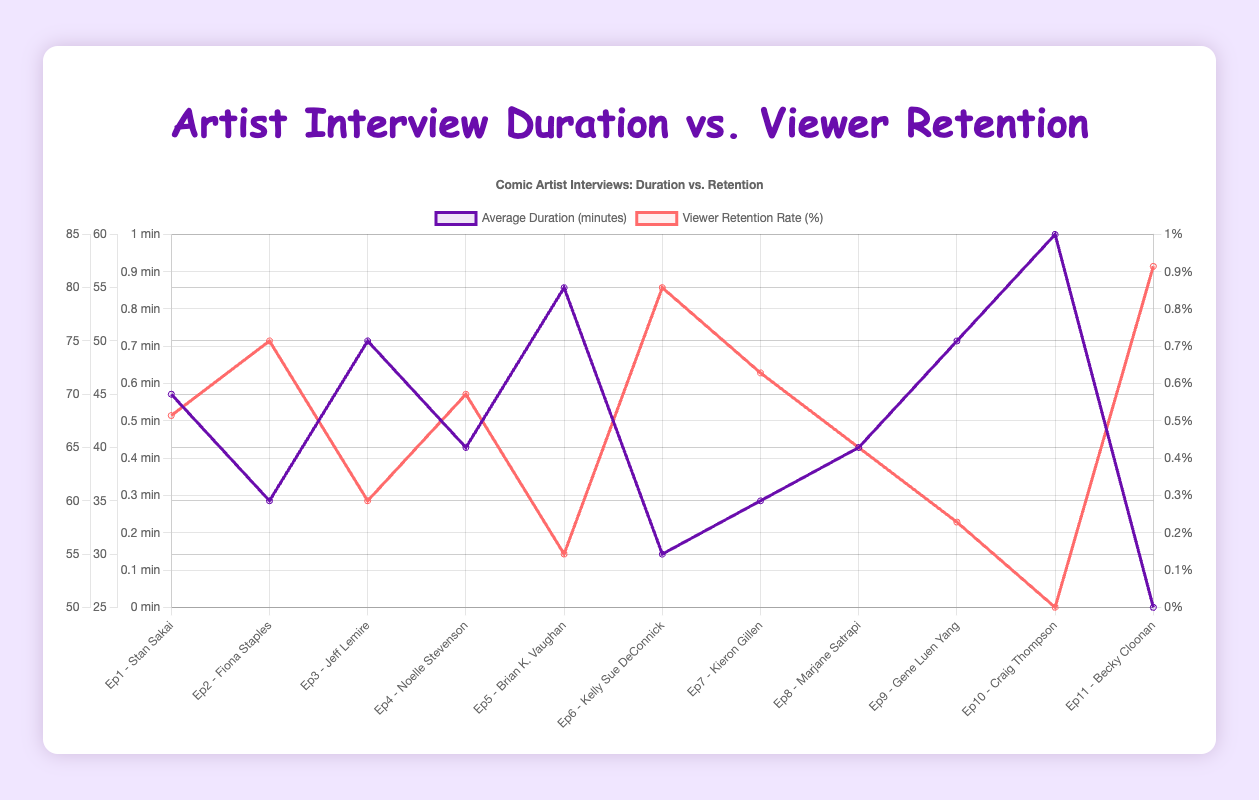Which episode had the highest viewer retention rate? From the chart, the episode with the highest viewer retention rate is identified as 'Ep11 - Becky Cloonan', with a viewer retention rate of 82%.
Answer: Ep11 - Becky Cloonan How many episodes have an average duration of 50 minutes or more? Examine the chart and count episodes that have an average duration of 50 minutes or more. These episodes are: 'Ep3 - Jeff Lemire', 'Ep5 - Brian K. Vaughan', 'Ep9 - Gene Luen Yang', and 'Ep10 - Craig Thompson'. That's a total of 4 episodes.
Answer: 4 What is the average viewer retention rate across all episodes? To find the average viewer retention rate, sum up the retention rates for all episodes and divide by the total number of episodes. The total retention rate is 68 + 75 + 60 + 70 + 55 + 80 + 72 + 65 + 58 + 50 + 82 = 735. There are 11 episodes, so the average is 735 / 11 ≈ 66.82.
Answer: 66.82% Which episode had the longest average interview duration and what was its viewer retention rate? From the chart, 'Ep10 - Craig Thompson' has the longest average interview duration at 60 minutes. Its corresponding viewer retention rate is 50%.
Answer: Ep10 - Craig Thompson, 50% Compare the average duration and retention rate of episodes with the shortest and longest durations. What do you observe? The episode with the shortest duration is 'Ep11 - Becky Cloonan' at 25 minutes, with a retention rate of 82%. The episode with the longest duration is 'Ep10 - Craig Thompson' at 60 minutes, with a retention rate of 50%. Shorter episodes tend to have a higher retention rate.
Answer: Shortest: 25 min, 82%; Longest: 60 min, 50% Is there a notable trend between interview duration and viewer retention rates? By reviewing the chart, it appears that episodes with shorter interview durations generally have higher viewer retention rates, suggesting a negative trend.
Answer: Negative trend Which episodes have a viewer retention rate of 70% or higher? Identify episodes from the chart with retention rates of at least 70%. These episodes are: 'Ep2 - Fiona Staples', 'Ep4 - Noelle Stevenson', 'Ep6 - Kelly Sue DeConnick', 'Ep7 - Kieron Gillen', and 'Ep11 - Becky Cloonan'.
Answer: Ep2, Ep4, Ep6, Ep7, Ep11 What is the total average duration of all episodes combined? Sum the average durations of all episodes from the chart: 45 + 35 + 50 + 40 + 55 + 30 + 35 + 40 + 50 + 60 + 25 = 465 minutes.
Answer: 465 minutes 